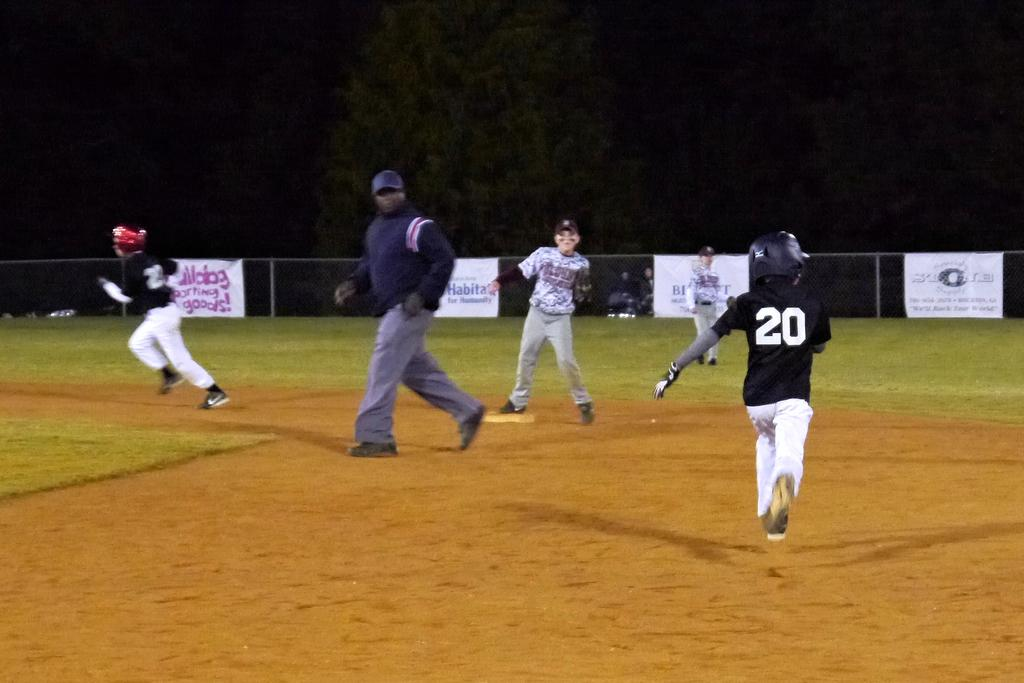<image>
Render a clear and concise summary of the photo. Baseball field with a Habitat for Humanity banner on the fence. 